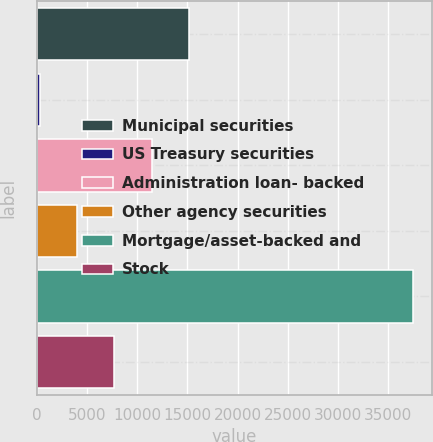<chart> <loc_0><loc_0><loc_500><loc_500><bar_chart><fcel>Municipal securities<fcel>US Treasury securities<fcel>Administration loan- backed<fcel>Other agency securities<fcel>Mortgage/asset-backed and<fcel>Stock<nl><fcel>15173.6<fcel>304<fcel>11456.2<fcel>4021.4<fcel>37478<fcel>7738.8<nl></chart> 